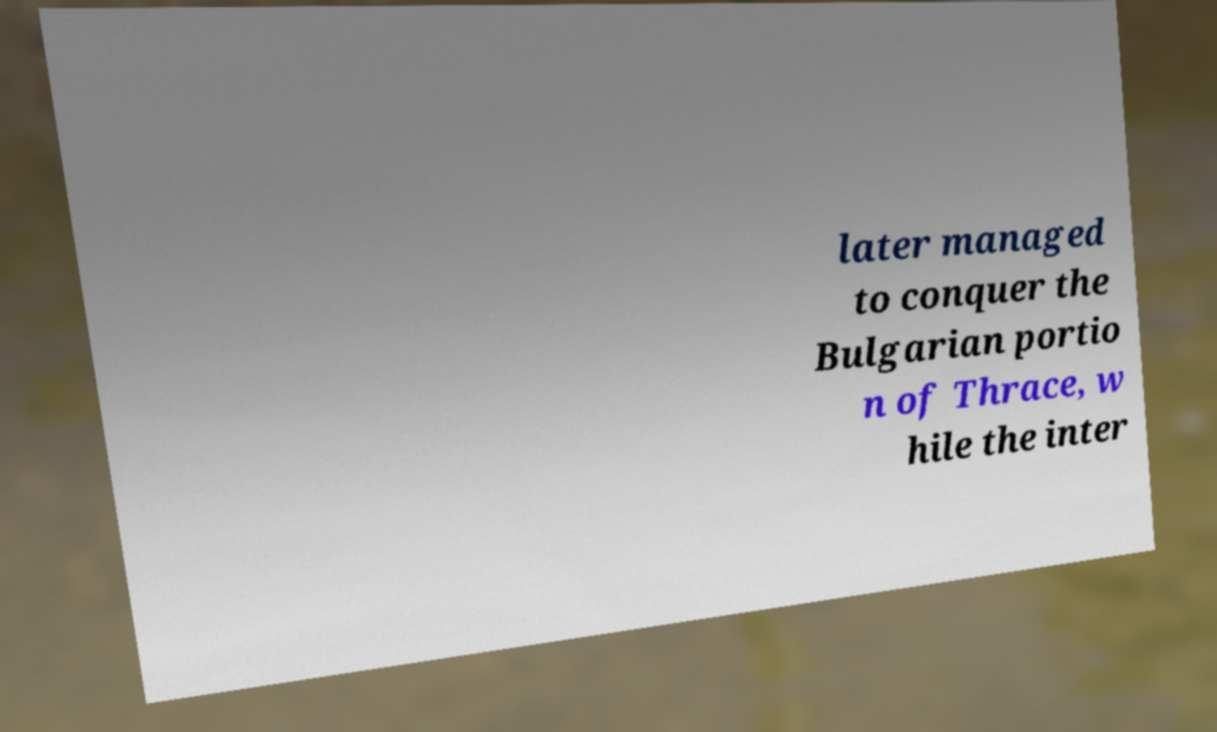Please read and relay the text visible in this image. What does it say? later managed to conquer the Bulgarian portio n of Thrace, w hile the inter 